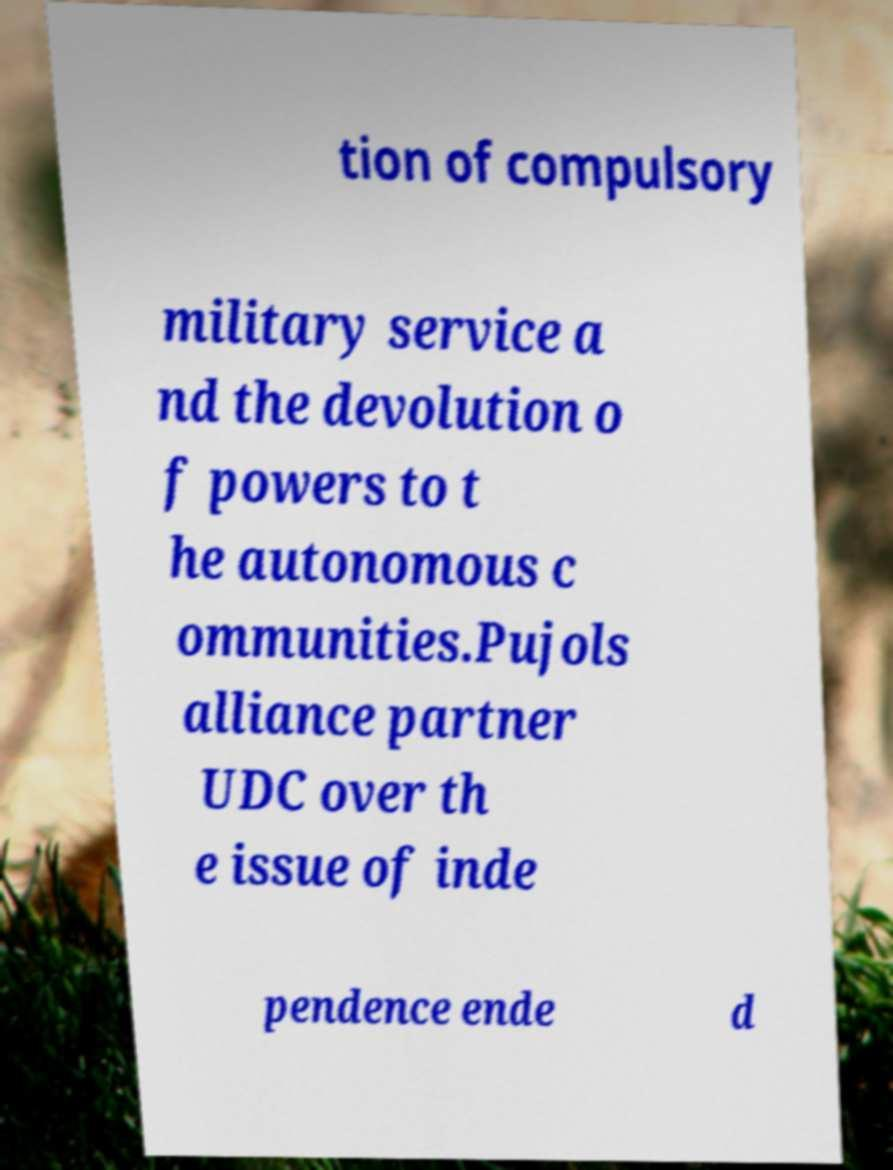What messages or text are displayed in this image? I need them in a readable, typed format. tion of compulsory military service a nd the devolution o f powers to t he autonomous c ommunities.Pujols alliance partner UDC over th e issue of inde pendence ende d 